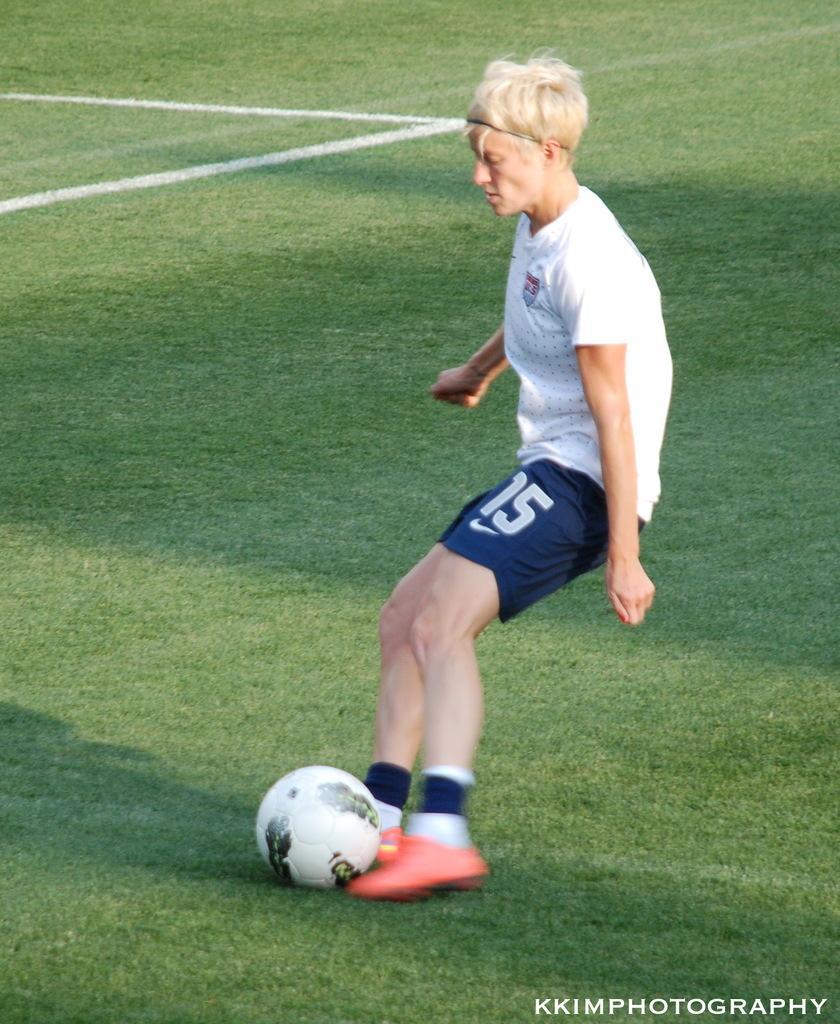Can you describe this image briefly? In this picture we can see a person who is playing with the ball. And this is grass. 